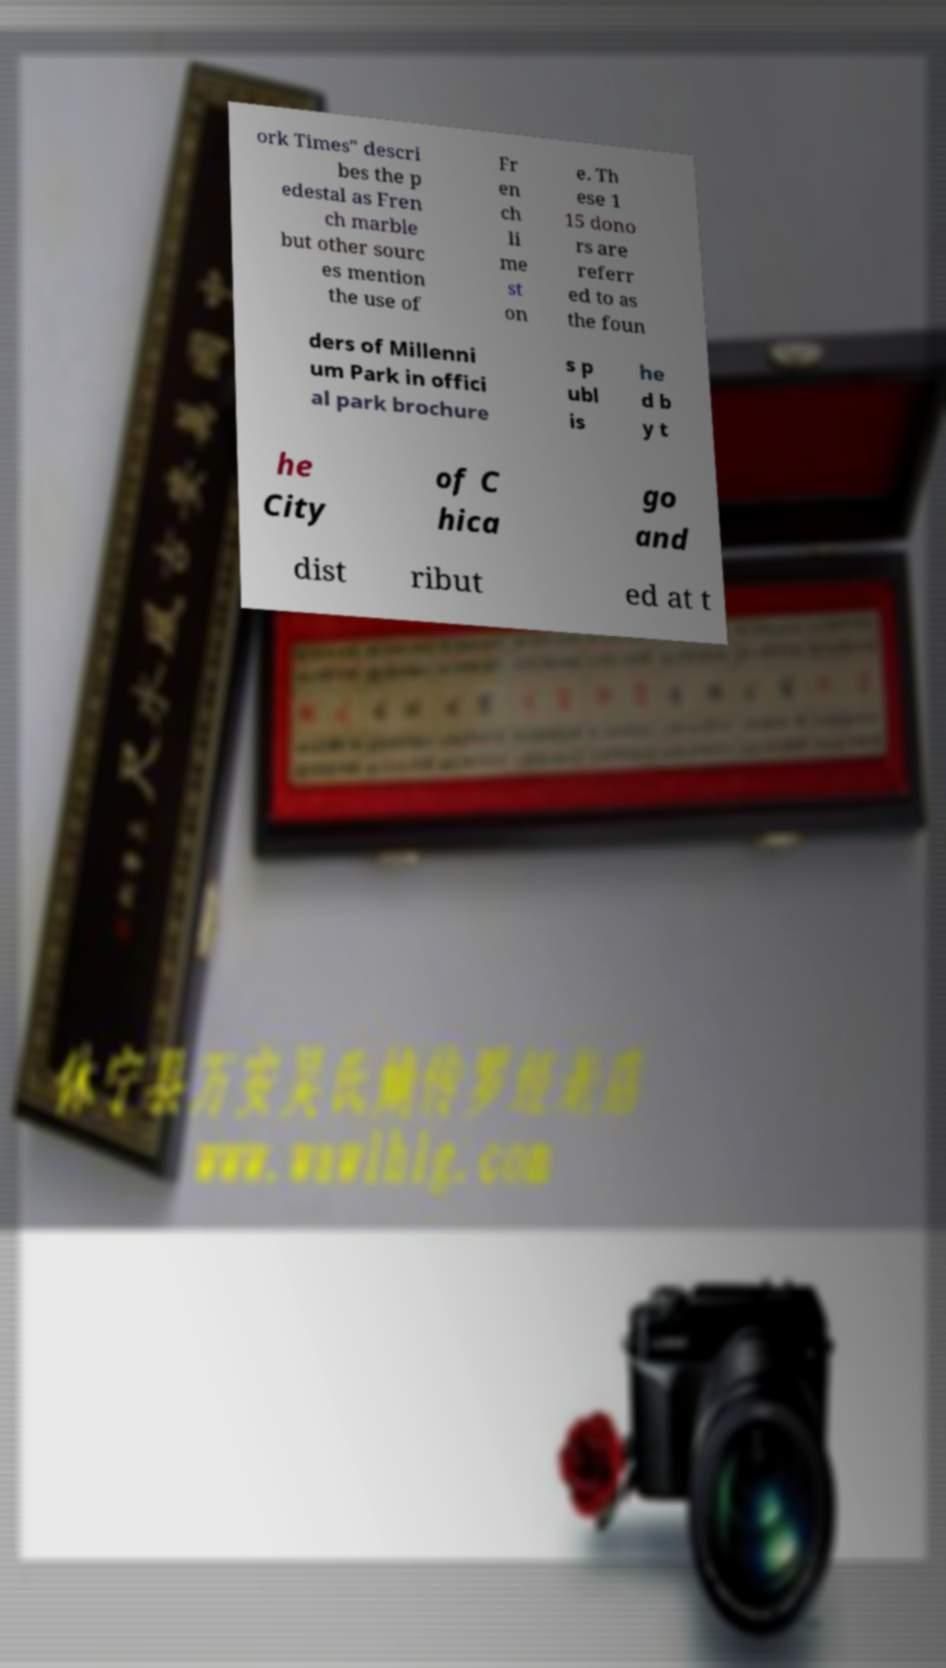For documentation purposes, I need the text within this image transcribed. Could you provide that? ork Times" descri bes the p edestal as Fren ch marble but other sourc es mention the use of Fr en ch li me st on e. Th ese 1 15 dono rs are referr ed to as the foun ders of Millenni um Park in offici al park brochure s p ubl is he d b y t he City of C hica go and dist ribut ed at t 